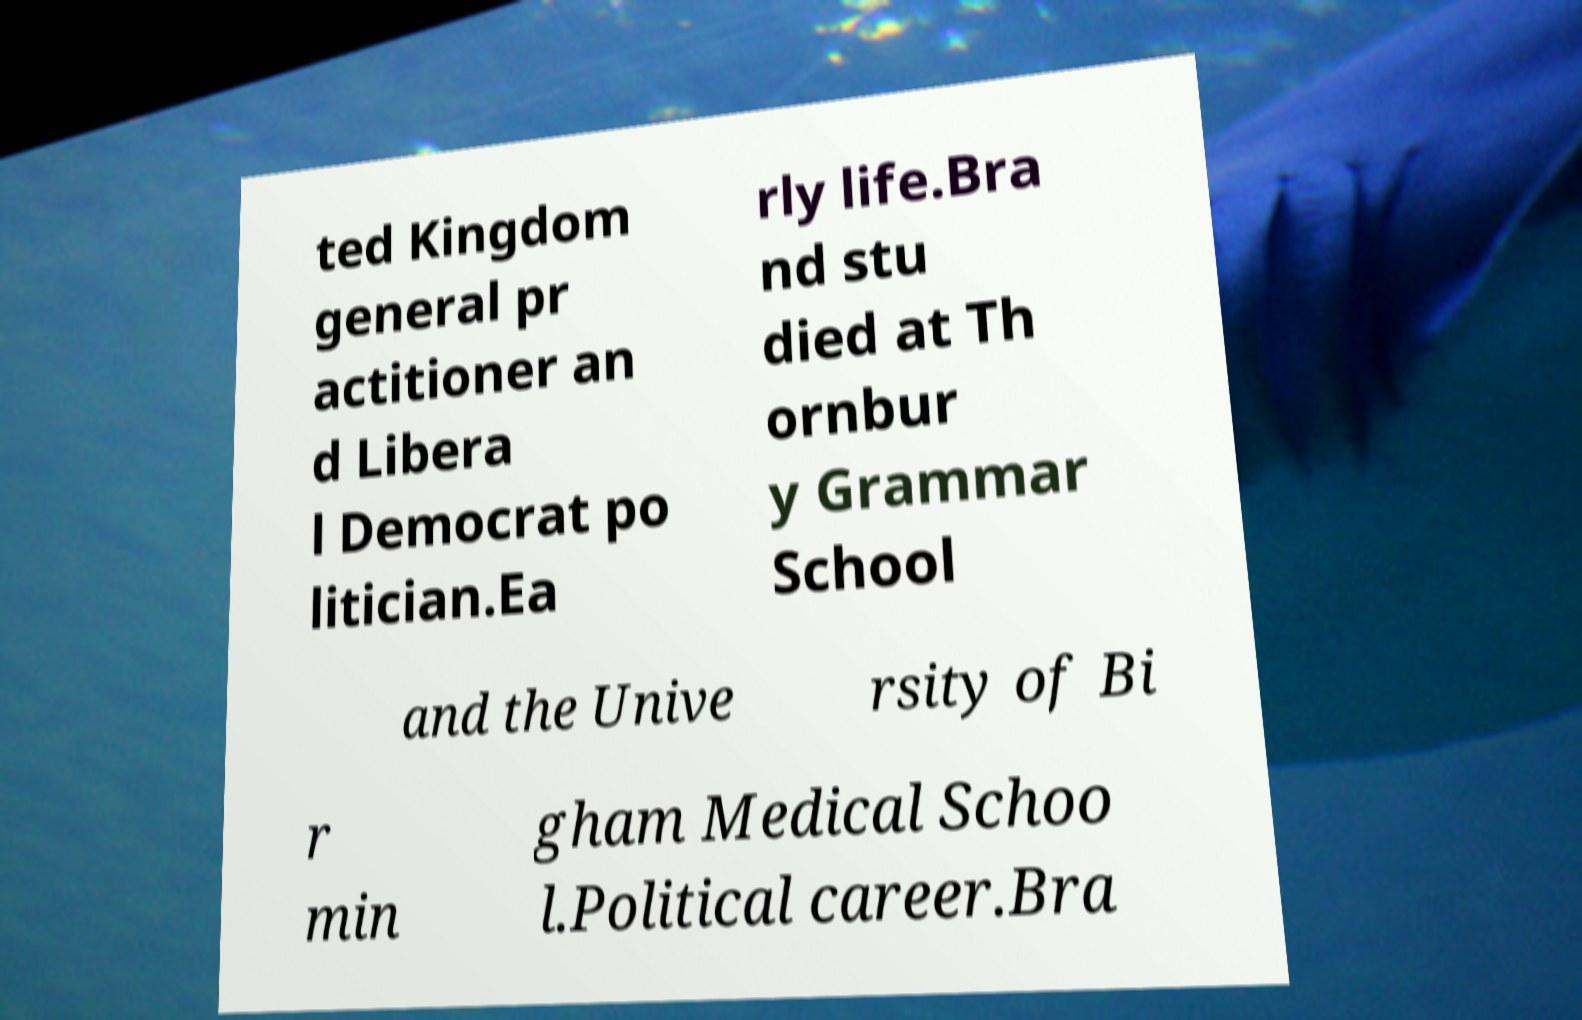I need the written content from this picture converted into text. Can you do that? ted Kingdom general pr actitioner an d Libera l Democrat po litician.Ea rly life.Bra nd stu died at Th ornbur y Grammar School and the Unive rsity of Bi r min gham Medical Schoo l.Political career.Bra 